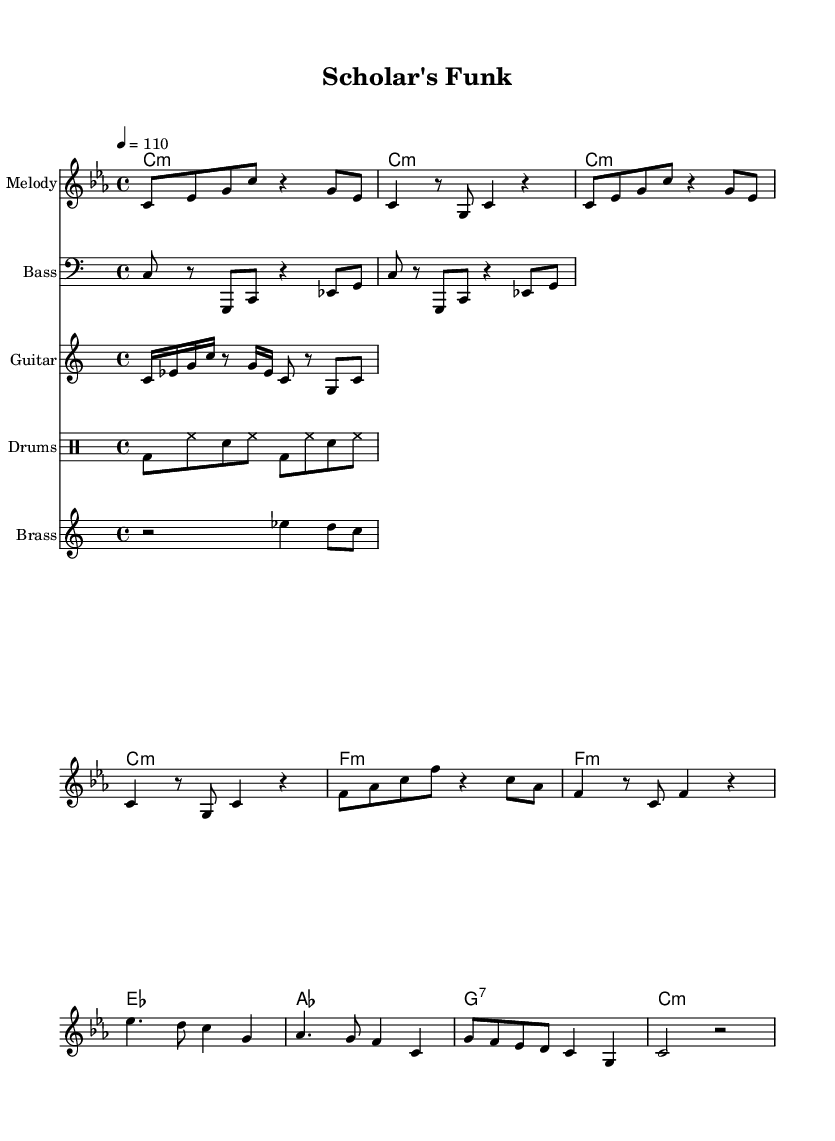What is the key signature of this music? The key signature is C minor, which has three flats (B♭, E♭, and A♭). This can be determined from the key signature notation in the music sheet.
Answer: C minor What is the time signature of this music? The time signature is 4/4, indicated clearly at the beginning of the score. This means there are four beats in each measure and the quarter note gets one beat.
Answer: 4/4 What is the tempo marking of this music? The tempo marking is set to quarter note equals 110 BPM, as indicated in the score. This specifies how fast the piece should be played.
Answer: 110 What is the first chord in the introduction? The first chord is C minor, denoted by the chord symbol 'c1:m' at the beginning of the introduction. The 'm' indicates it is a minor chord.
Answer: C minor How many measures are in the chorus section? The chorus consists of four measures. This can be counted by identifying the measure lines throughout the chorus section.
Answer: 4 Which instrument plays the bass line? The bass line is played by the Bass instrument, as indicated by the instrument name at the beginning of that staff.
Answer: Bass What rhythmic elements are typical in Funk music as seen in this score? The rhythmic elements in Funk music include syncopation and strong backbeats, as shown in the drum pattern and brass hits sections that emphasize the groove.
Answer: Syncopation 